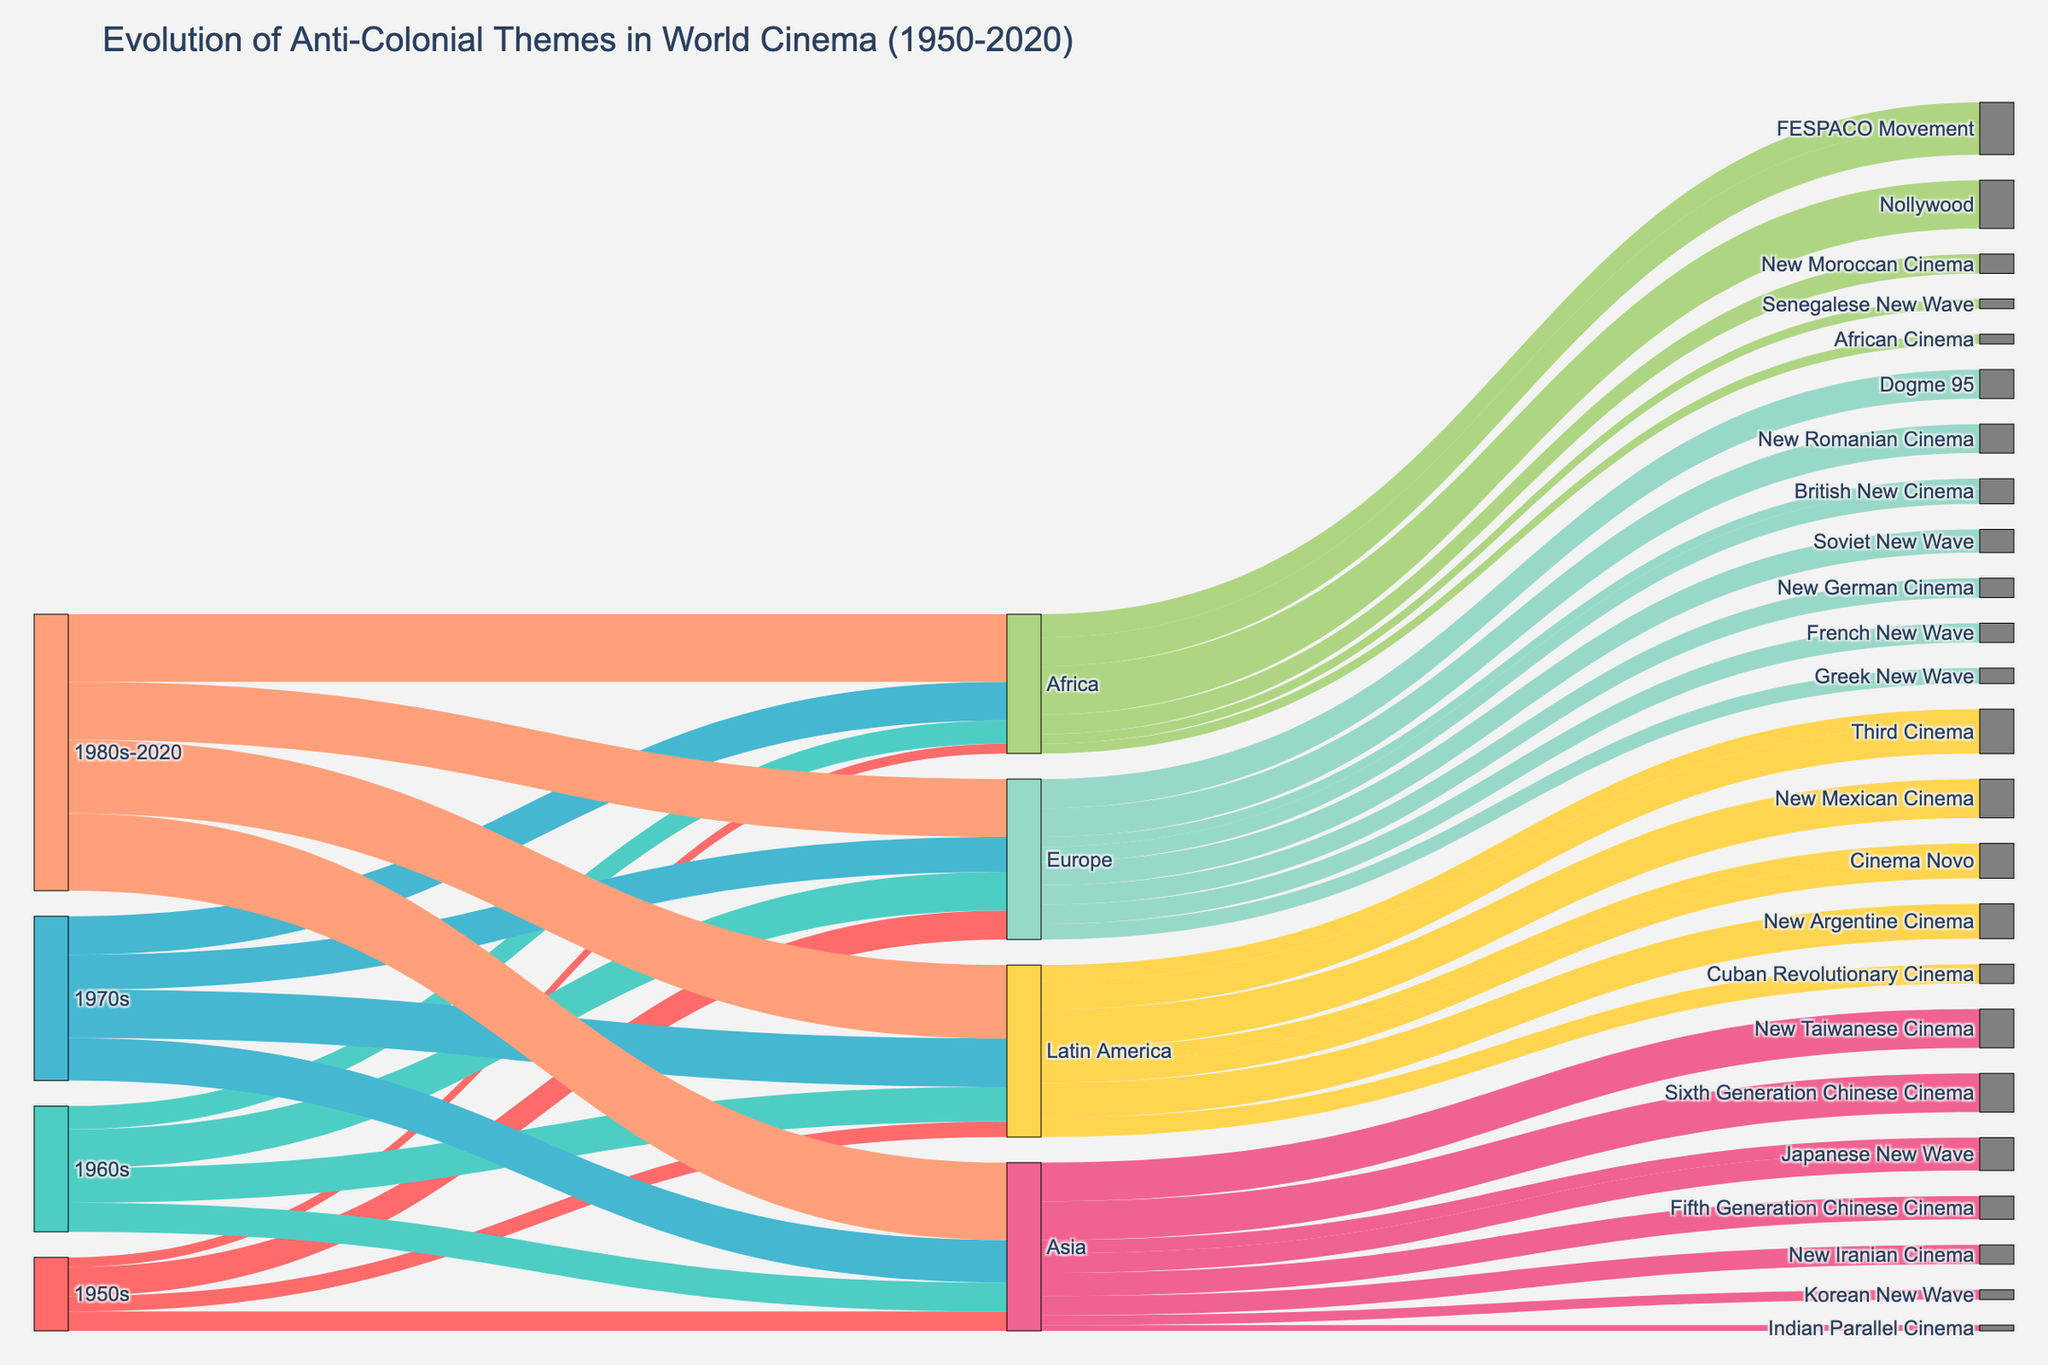What is the title of the Sankey diagram? The title of the Sankey diagram is mentioned at the top of the figure. It helps summarize the main topic of the visual representation.
Answer: Evolution of Anti-Colonial Themes in World Cinema (1950-2020) How many links are connected to the "1950s" node? To find out the number of links connected to the "1950s" node, look at the figure and count the arrows originating from the "1950s" node.
Answer: 4 Which continent had the highest number of related movements in the 1980s-2020? Observe the links from the "1980s-2020" node and identify which continent has the highest count of connections. Sum up the distinctive film movements for each continent within this period.
Answer: Asia What is the flow value from "Africa" in the 1970s to its related film movements? Locate the node "Africa" within the 1970s segment and find the associated arrows to its film movements. Sum the values indicated on these arrows.
Answer: 20 Compare the amount of anti-colonial themed films in the 1960s versus the 1950s for Latin America. Identify the flow values directed towards Latin America for the 1950s and the 1960s from their respective nodes. Subtract the 1950s value from the 1960s value to find the difference.
Answer: 10 more in 1960s Which film movement had the highest flow value in Africa in the "1980s-2020" period? Look at the links branching out from the "Africa" node in the 1980s-2020 section to identify which film movement has the highest value.
Answer: Nollywood Which decade experienced the smallest flow increase in anti-colonial themes in Europe? For each decade, find the difference in flow values towards Europe compared to the previous decade. Calculate which transition period had the smallest increase.
Answer: 1970s How does the flow value to "New Taiwanese Cinema" compare to "Sixth Generation Chinese Cinema" within the 1980s-2020 period? Look at the 1980s-2020 node and examine links to "New Taiwanese Cinema" and "Sixth Generation Chinese Cinema". Compare their values.
Answer: They are equal What is the total value of anti-colonial themed films globally in the 1970s? Sum all the flow values from the 1970s node to all the continents. This value represents the total anti-colonial films for that decade.
Answer: 85 Which Asian film movement had more value in the 1960s: "Japanese New Wave" or "Korean New Wave"? Check the flow values coming from Asia in the 1960s node towards "Japanese New Wave" and "Korean New Wave". Compare their values.
Answer: Japanese New Wave 